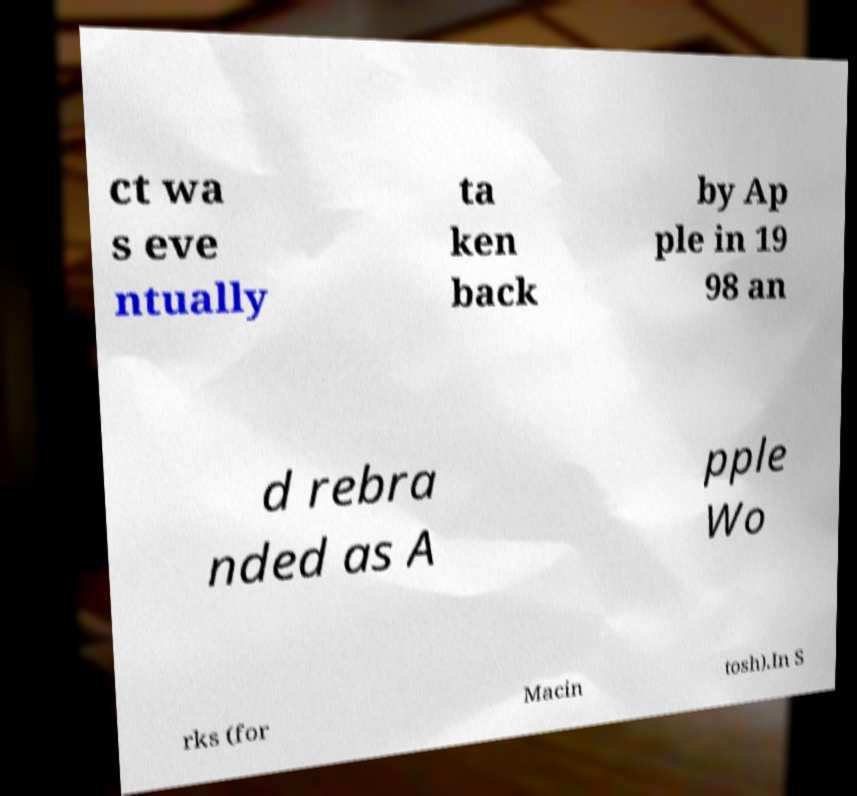Please read and relay the text visible in this image. What does it say? ct wa s eve ntually ta ken back by Ap ple in 19 98 an d rebra nded as A pple Wo rks (for Macin tosh).In S 